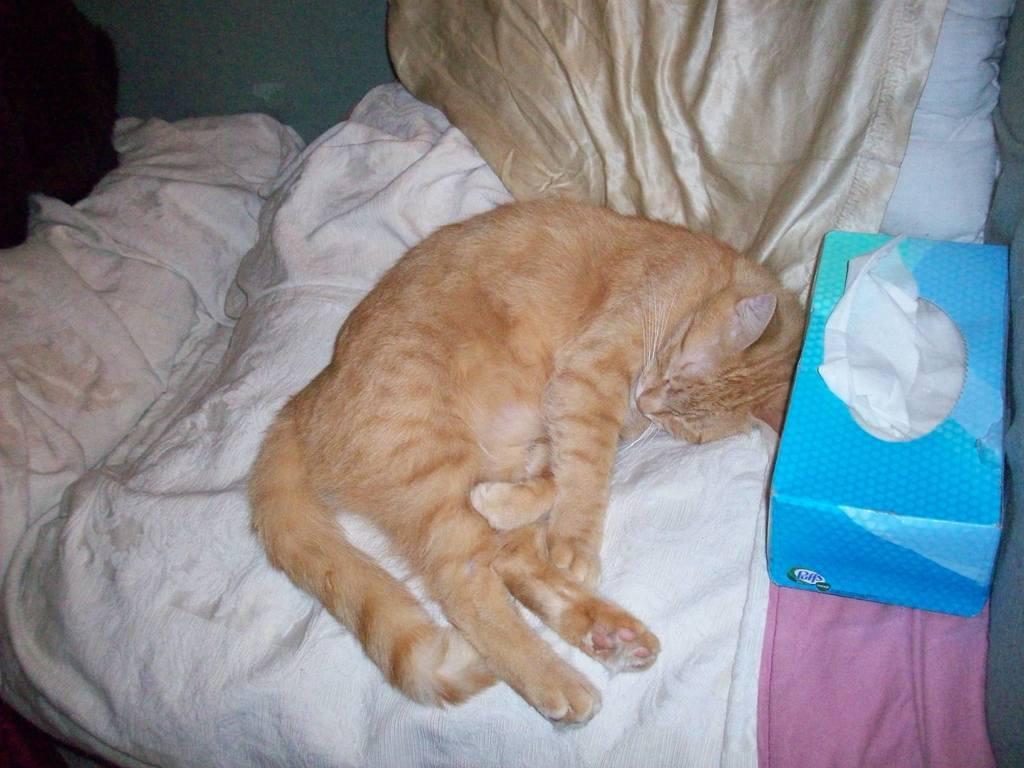Please provide a concise description of this image. In this image I can see a white colour cloth and on it I can see a cream colour cat. I can see see a pink colour cloth, a blue colour tissue box and few other things over here. 